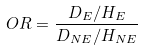Convert formula to latex. <formula><loc_0><loc_0><loc_500><loc_500>O R = \frac { D _ { E } / H _ { E } } { D _ { N E } / H _ { N E } }</formula> 